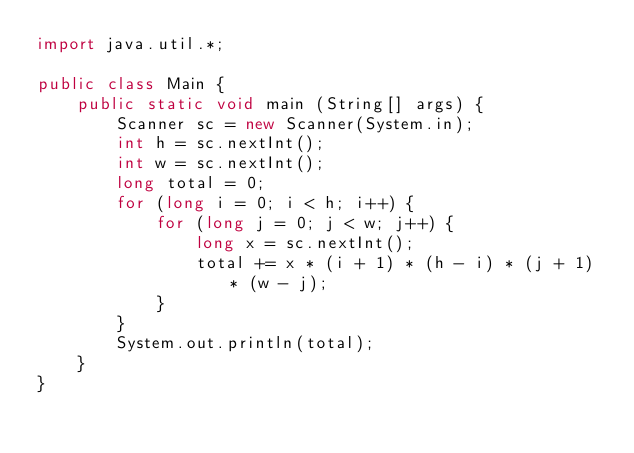<code> <loc_0><loc_0><loc_500><loc_500><_Java_>import java.util.*;

public class Main {
	public static void main (String[] args) {
		Scanner sc = new Scanner(System.in);
		int h = sc.nextInt();
		int w = sc.nextInt();
		long total = 0;
		for (long i = 0; i < h; i++) {
		    for (long j = 0; j < w; j++) {
		        long x = sc.nextInt();
		        total += x * (i + 1) * (h - i) * (j + 1) * (w - j);
		    }
		}
	    System.out.println(total);
	}
}

</code> 